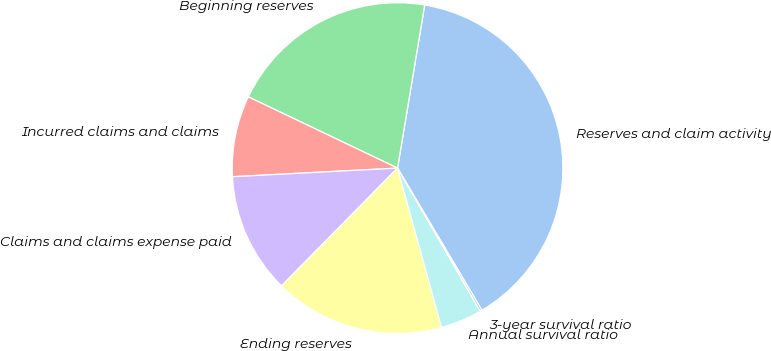<chart> <loc_0><loc_0><loc_500><loc_500><pie_chart><fcel>Reserves and claim activity<fcel>Beginning reserves<fcel>Incurred claims and claims<fcel>Claims and claims expense paid<fcel>Ending reserves<fcel>Annual survival ratio<fcel>3-year survival ratio<nl><fcel>38.85%<fcel>20.54%<fcel>7.92%<fcel>11.79%<fcel>16.67%<fcel>4.05%<fcel>0.19%<nl></chart> 